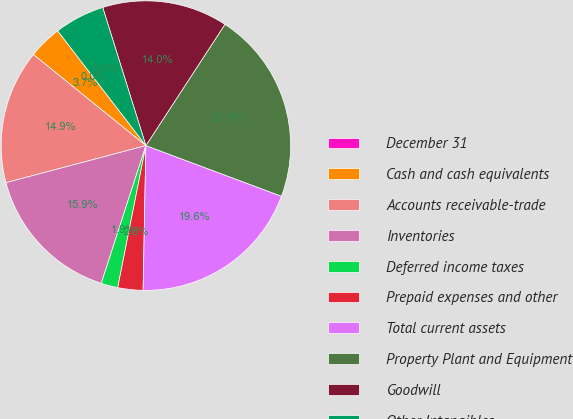Convert chart to OTSL. <chart><loc_0><loc_0><loc_500><loc_500><pie_chart><fcel>December 31<fcel>Cash and cash equivalents<fcel>Accounts receivable-trade<fcel>Inventories<fcel>Deferred income taxes<fcel>Prepaid expenses and other<fcel>Total current assets<fcel>Property Plant and Equipment<fcel>Goodwill<fcel>Other Intangibles<nl><fcel>0.0%<fcel>3.74%<fcel>14.95%<fcel>15.89%<fcel>1.87%<fcel>2.81%<fcel>19.62%<fcel>21.49%<fcel>14.02%<fcel>5.61%<nl></chart> 